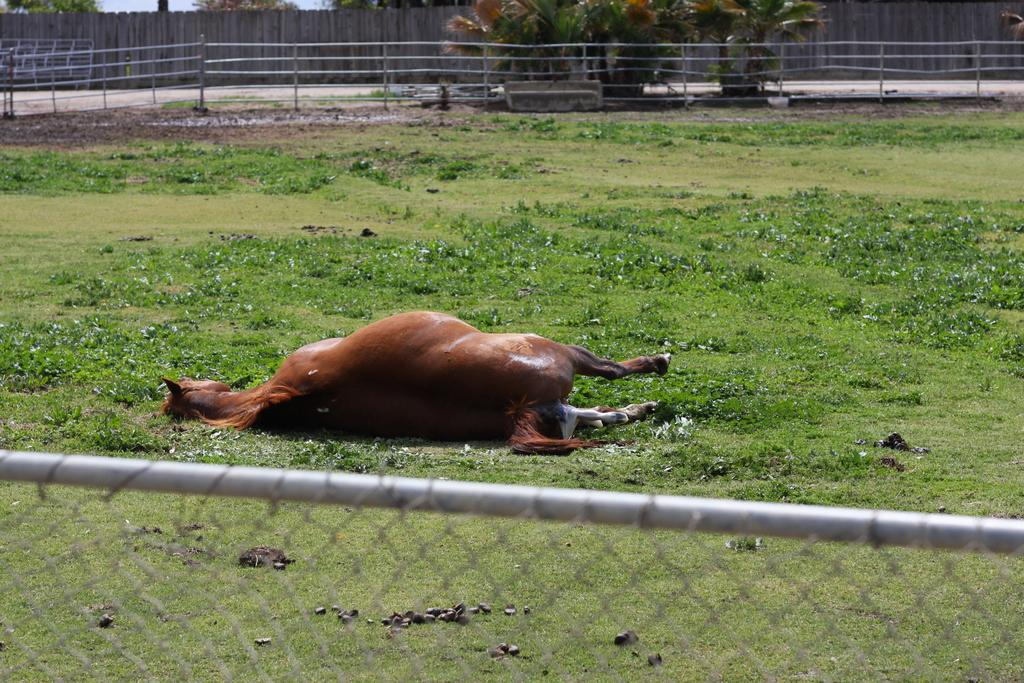What animal can be seen lying on the ground in the image? There is a horse lying on the ground in the image. What type of vegetation is visible in the image? There are plants and grass visible in the image. What type of fencing can be seen in the image? There is a metal fence and a wooden fence in the image. What type of containers are holding plants in the image? There are plants in pots in the image. What structure is visible in the image? There is a pole in the image. What part of the natural environment is visible in the image? The sky is visible in the image. What type of hook can be seen hanging from the wooden fence in the image? There is no hook present on the wooden fence in the image. 